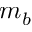<formula> <loc_0><loc_0><loc_500><loc_500>m _ { b }</formula> 